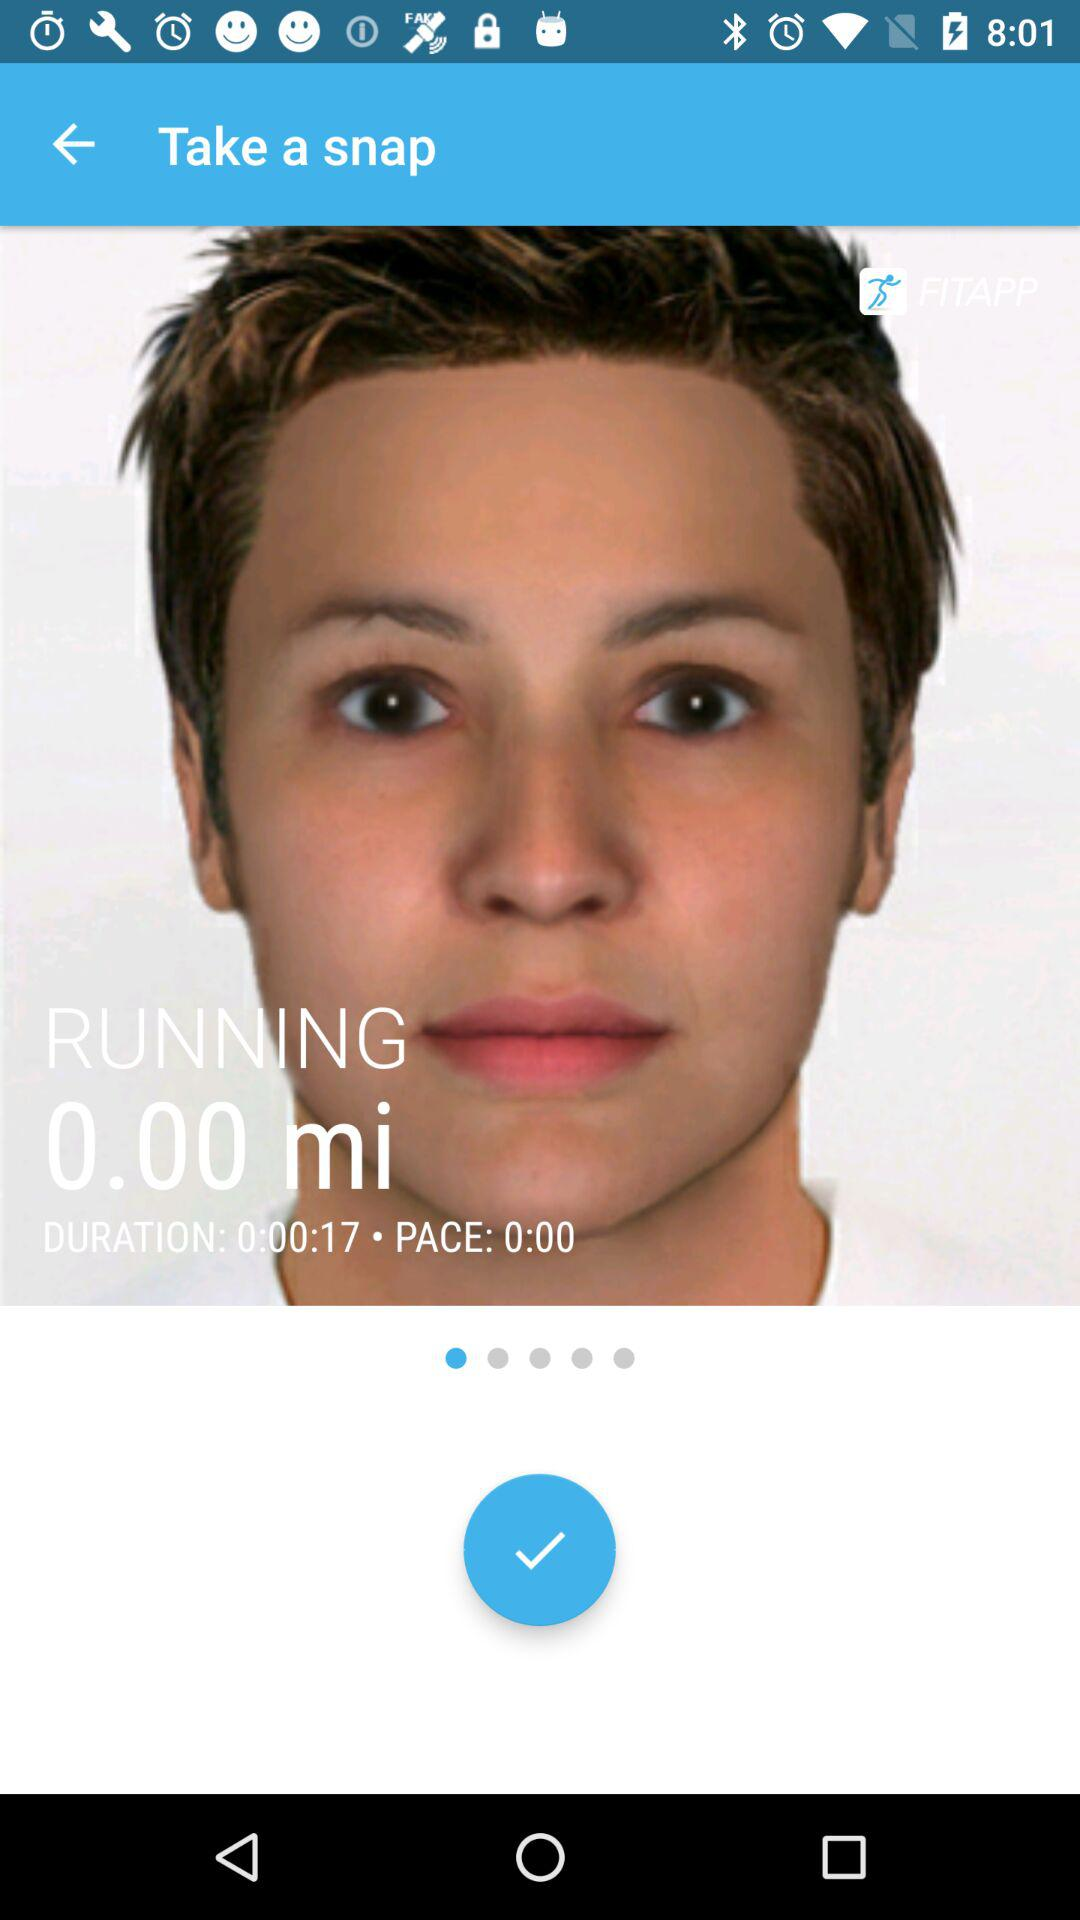What is the distance the user has run?
Answer the question using a single word or phrase. 0.00 mi 